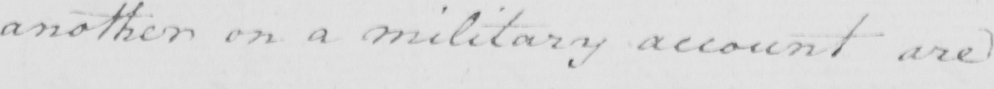Please transcribe the handwritten text in this image. another on a military account are 